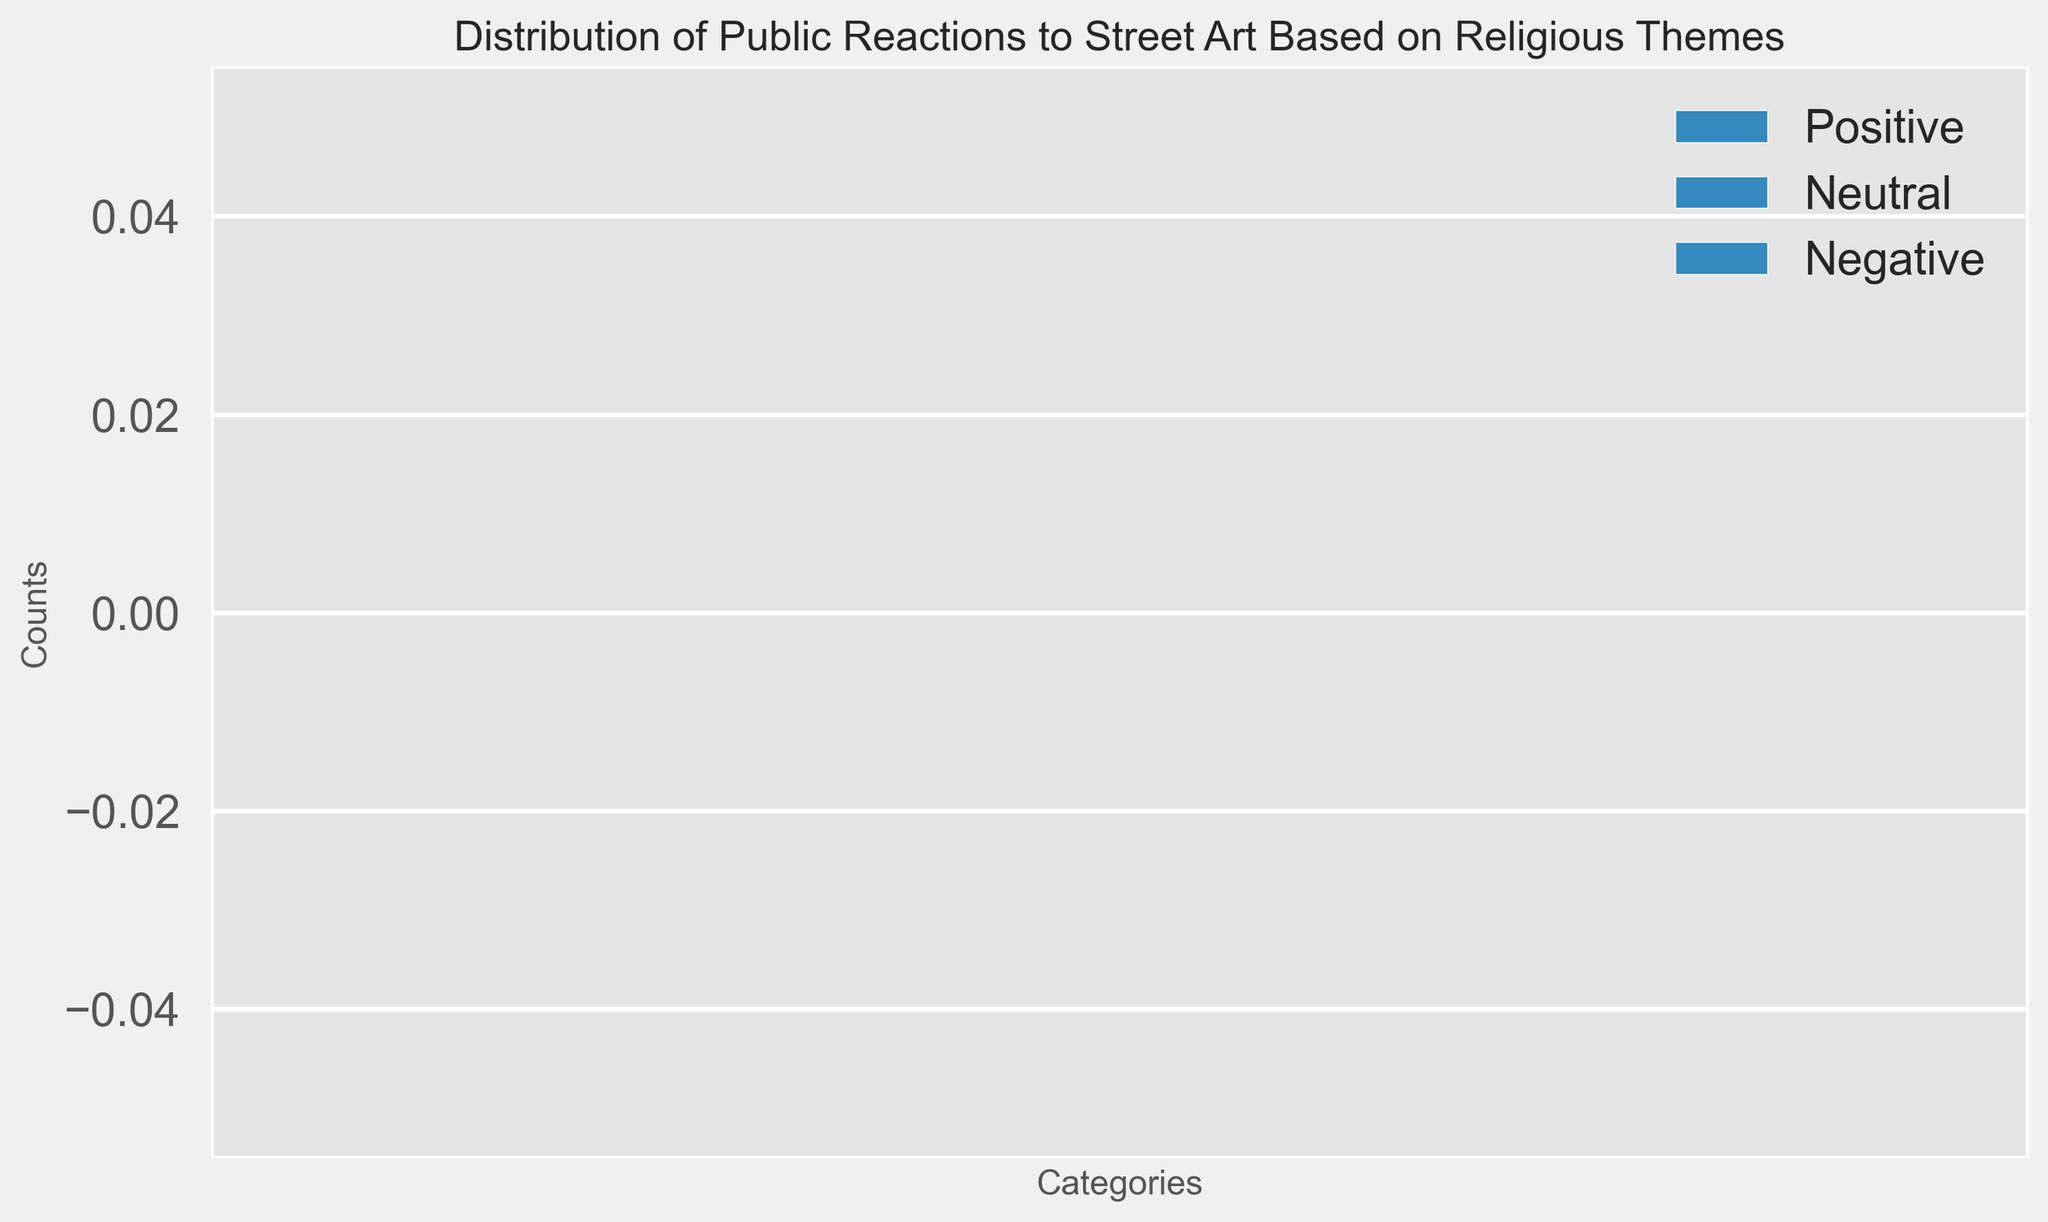What's the total number of positive and neutral responses combined? To find the total number of positive and neutral responses, first locate the height of the 'Positive' and 'Neutral' bars for each category and sum them. Then, sum these results together.
Answer: [sum of all categories positive] + [sum of all categories neutral] Which category received the highest number of negative responses? Look at the height of the 'Negative' bars across all categories and identify which one is tallest.
Answer: [category name] Is the number of positive responses greater than the combined number of neutral and negative responses in any category? Compare the height of the 'Positive' bar to the sum of the heights of the 'Neutral' and 'Negative' bars for each category.
Answer: [Yes/No] + [Category name, if applicable] How does the number of neutral responses compare to the number of negative responses in the least responded category? First, identify the least responded category by adding up all the responses for each category and finding the smallest sum. Then, compare the heights of the 'Neutral' and 'Negative' bars in that category.
Answer: [Neutral is greater/less/equal to Negative] + [specific values for better understanding] What is the visual difference between the number of positive responses and the number of neutral responses in the most responded category? Identify the category with the highest total responses by summing the heights of all bars per category and finding the largest sum. Then compare the height of the 'Positive' bar to the 'Neutral' bar in that category.
Answer: [Positive is greater/less/equal to Neutral] + [specific values for better understanding] How many more positive responses are there compared to negative responses in the category with the most negative feedback? Identify the category with the highest 'Negative' bar, then subtract the height of the 'Negative' bar from the 'Positive' bar in that category.
Answer: [Specific value] What's the average number of responses (combining positive, neutral, and negative) across all categories? Sum all the 'Positive', 'Neutral', and 'Negative' responses across all categories and then divide by the number of categories.
Answer: [specific average value] Which bar (Positive, Neutral, or Negative) is most frequently the shortest across all categories? Compare the heights of 'Positive', 'Neutral', and 'Negative' bars in each category and count the frequencies of which is the shortest bar.
Answer: [Positive/Neutral/Negative] Is there any category where all three types of responses are equal in number? Look at the heights of 'Positive', 'Neutral', and 'Negative' bars for each category to see if there's any where all three bars are of equal height.
Answer: [Yes/No] What is the difference between the highest and lowest number of positive responses among the categories? Identify the maximum and minimum heights of the 'Positive' bars across all categories and subtract the minimum from the maximum.
Answer: [specific value] 